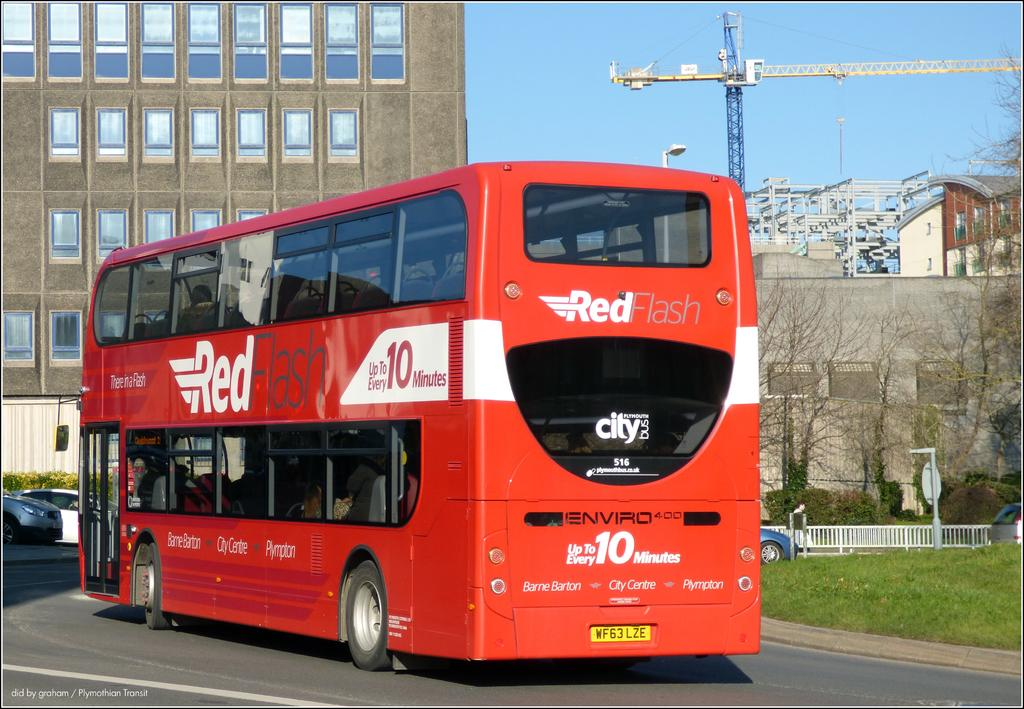<image>
Offer a succinct explanation of the picture presented. The red bus had the words Red Flash on top 